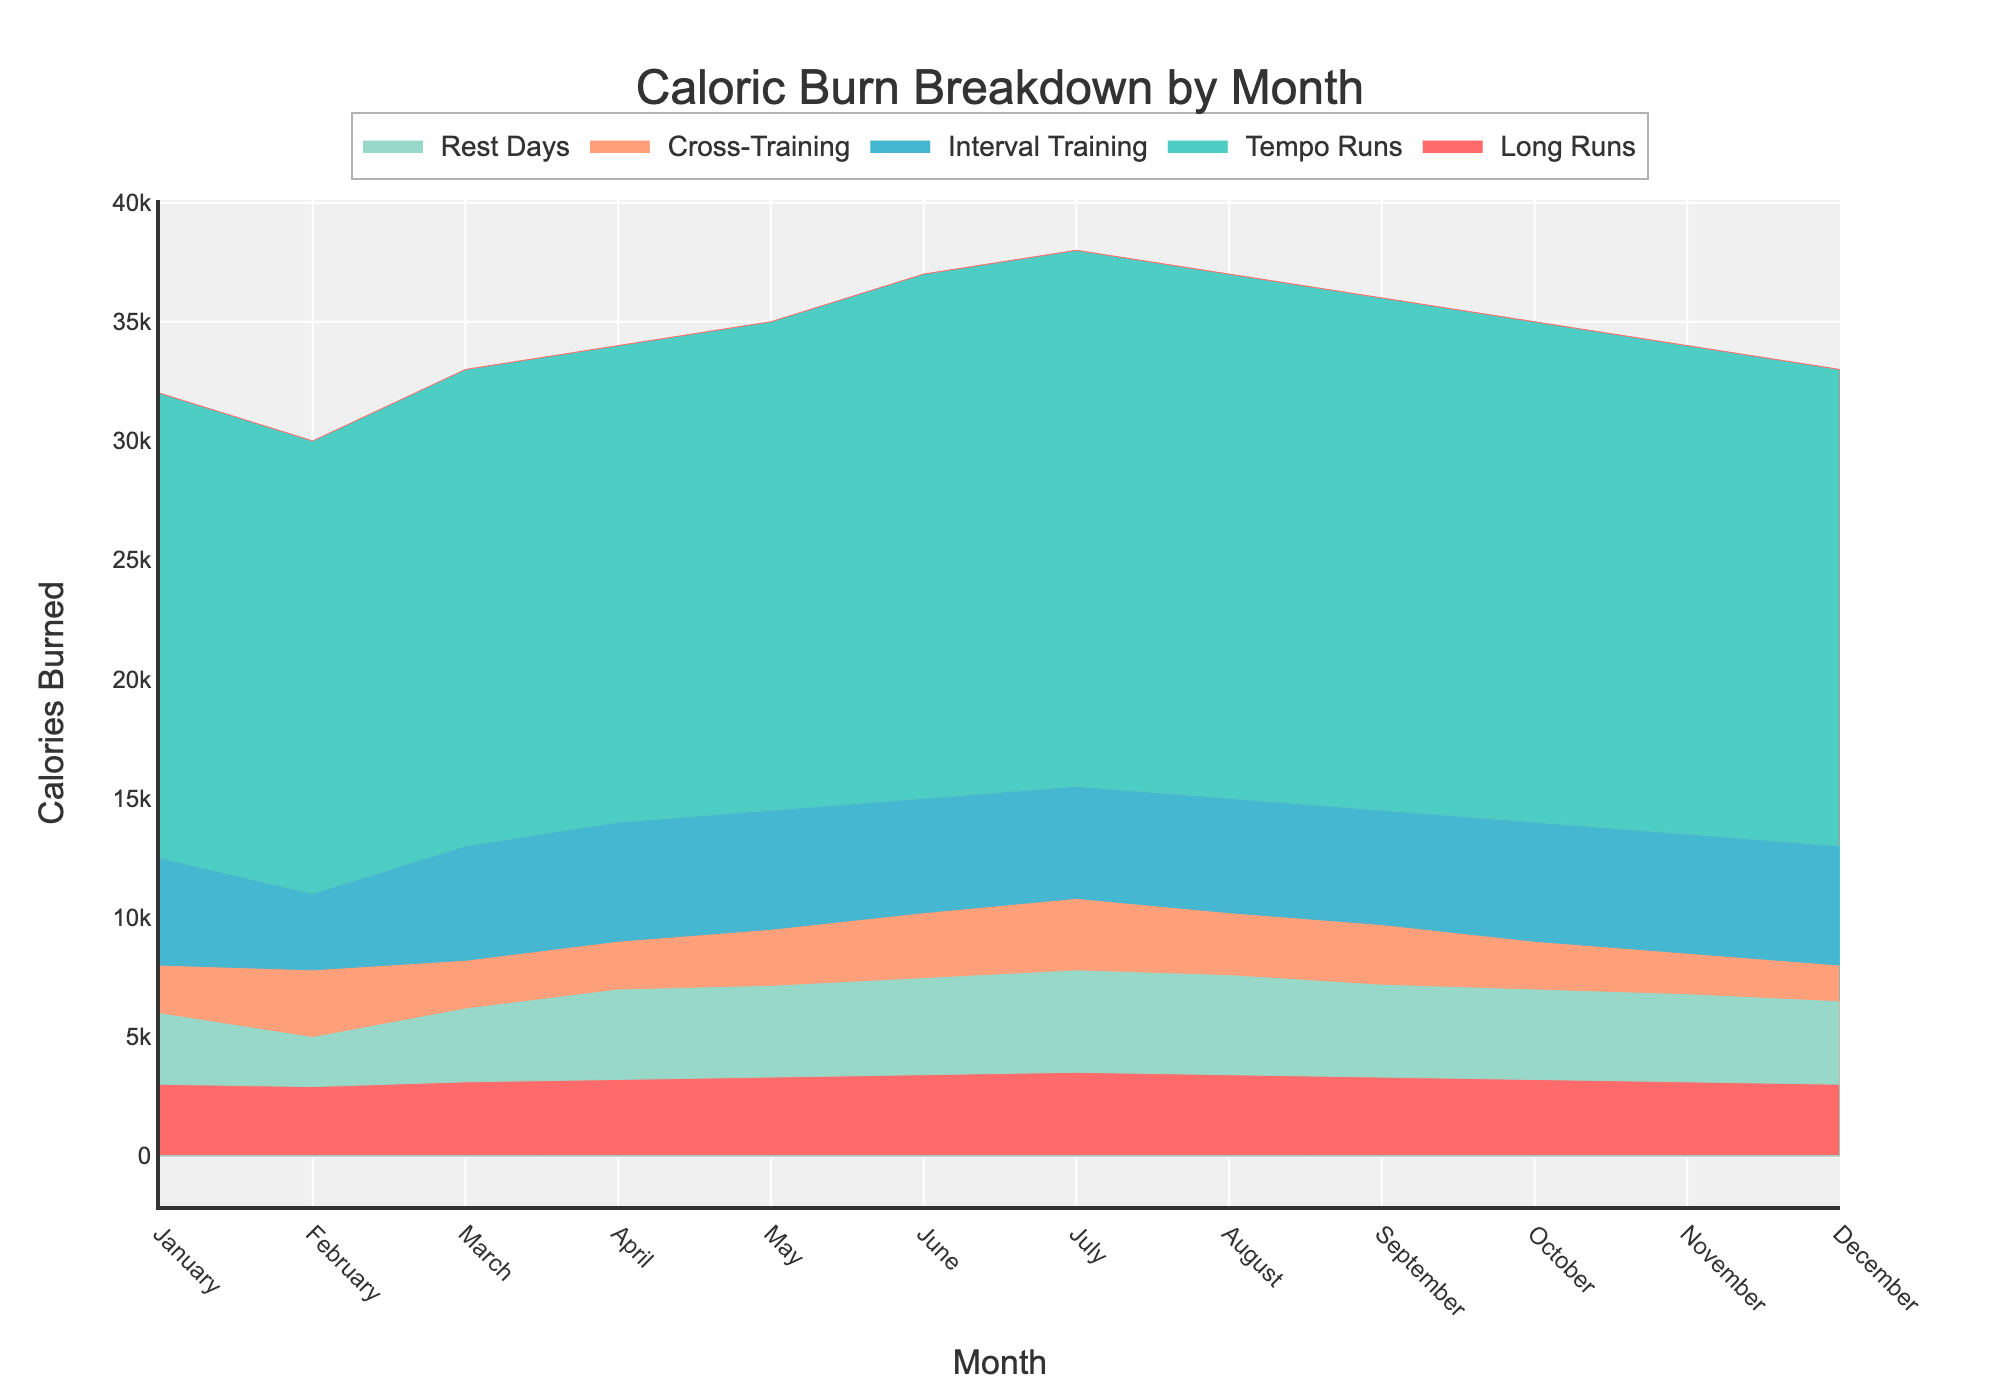What is the title of the figure? The title is prominently displayed at the top of the chart, and it reads "Caloric Burn Breakdown by Month".
Answer: Caloric Burn Breakdown by Month How many activity types are represented in the figure? The figure uses different colors to represent each activity type, and there are five colors in total, indicating five activity types.
Answer: 5 Which month has the highest caloric burn from Long Runs? By observing the figure, the area representing Long Runs reaches its maximum in July, which indicates the highest caloric burn from Long Runs in that month.
Answer: July What is the total caloric burn in May from all activities? Sum up the values for Long Runs (35000), Tempo Runs (14500), Interval Training (9500), Cross-Training (7150), and Rest Days (3350), which equals 69500.
Answer: 69500 How does the caloric burn from Interval Training change from February to March? The figure shows that the area for Interval Training increases slightly from 7800 in February to 8200 in March, indicating a rise of 400 calories.
Answer: It increases by 400 calories Which activity type has the largest contribution to caloric burn in December? The area at the top of December's column, representing Long Runs, is the largest compared to other activities for that month.
Answer: Long Runs Which two consecutive months show the largest increase in caloric burn from Tempo Runs? The caloric burn from Tempo Runs increases from 12500 in January to 13000 in March, but the largest increase is from April (14000) to July (15500), which is an increase of 1500 calories.
Answer: April to July Is the caloric burn from Cross-Training higher in June or August? By comparing the areas representing Cross-Training for June and August, it's clear that June has a slightly larger area, representing 7500 calories versus 7600 in August.
Answer: August In which month do Rest Days contribute the least to caloric burn? The smallest area for Rest Days is seen in February, representing the lowest caloric burn of 2900 calories.
Answer: February What is the second highest peak of caloric burn from Long Runs across the year? The highest peak is in July (38000 calories), and the second highest is in June (37000 calories).
Answer: June 